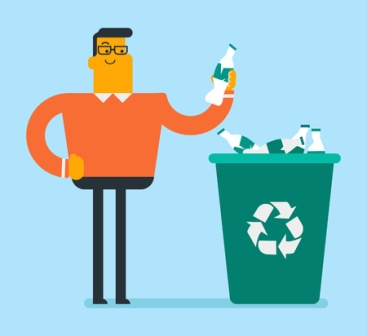Can you describe the attire and action of the man in the image? The man in the image is wearing glasses and an orange sweater paired with black pants. He is holding a green bottle in his right hand, appearing to be in the middle of recycling. There is a green recycling bin filled with white bottles next to him, reinforcing the theme of recycling and environmental care. 